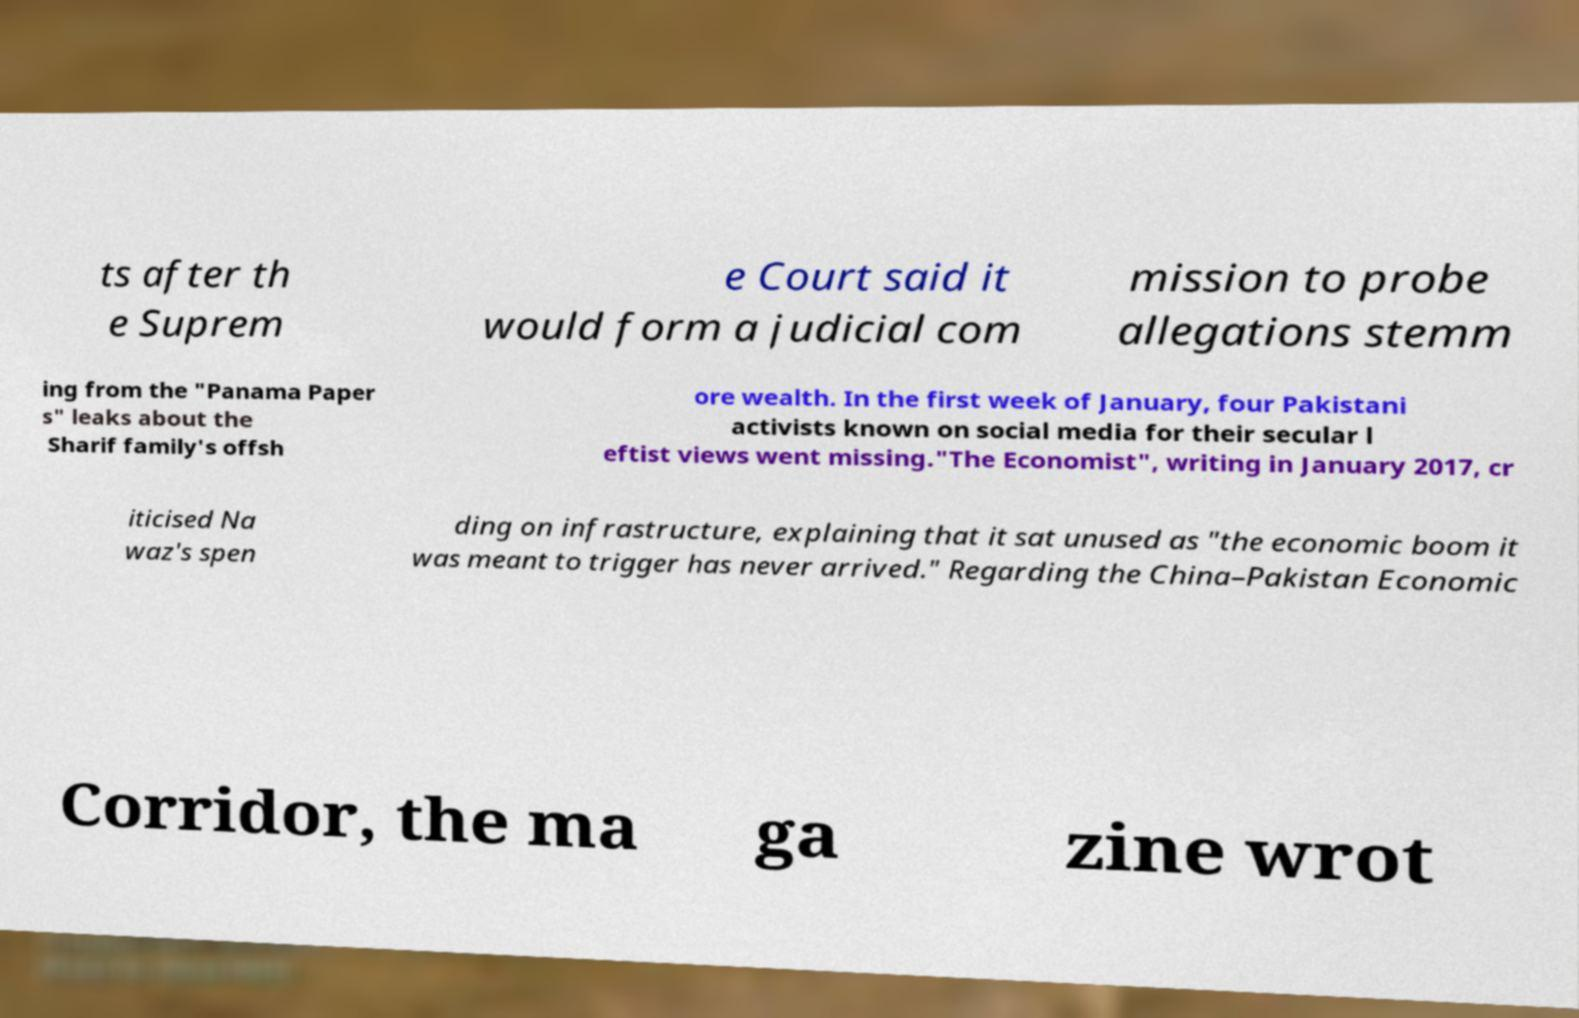There's text embedded in this image that I need extracted. Can you transcribe it verbatim? ts after th e Suprem e Court said it would form a judicial com mission to probe allegations stemm ing from the "Panama Paper s" leaks about the Sharif family's offsh ore wealth. In the first week of January, four Pakistani activists known on social media for their secular l eftist views went missing."The Economist", writing in January 2017, cr iticised Na waz's spen ding on infrastructure, explaining that it sat unused as "the economic boom it was meant to trigger has never arrived." Regarding the China–Pakistan Economic Corridor, the ma ga zine wrot 